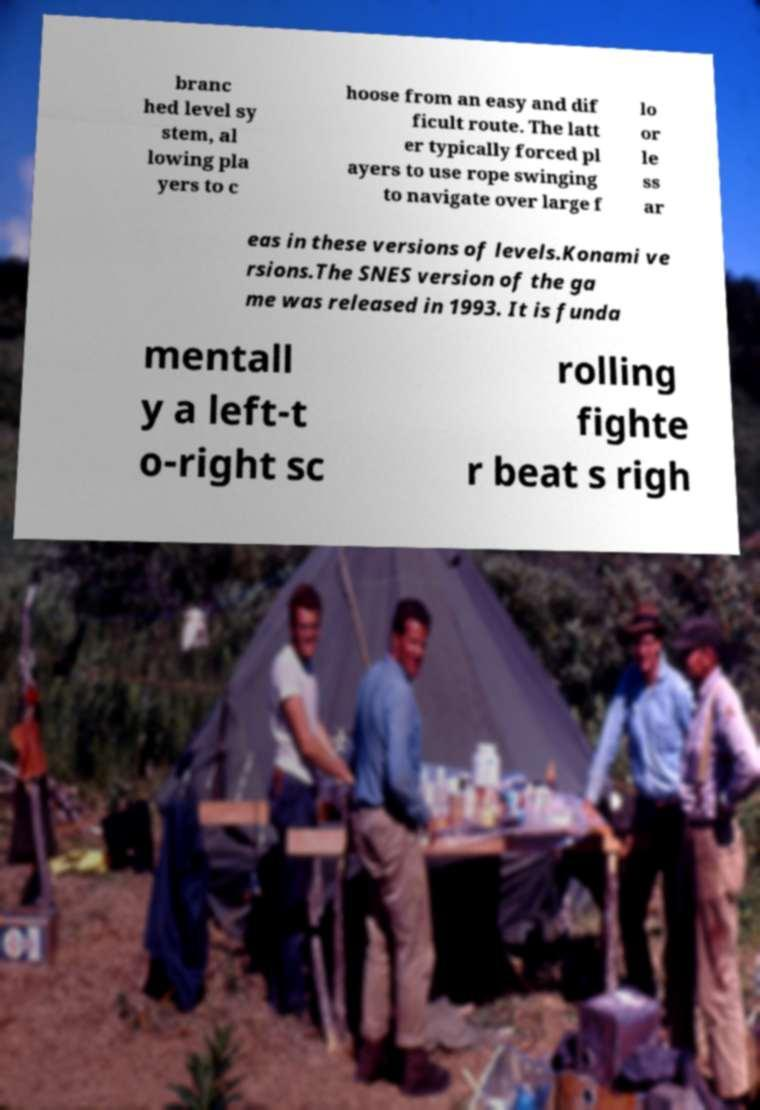For documentation purposes, I need the text within this image transcribed. Could you provide that? branc hed level sy stem, al lowing pla yers to c hoose from an easy and dif ficult route. The latt er typically forced pl ayers to use rope swinging to navigate over large f lo or le ss ar eas in these versions of levels.Konami ve rsions.The SNES version of the ga me was released in 1993. It is funda mentall y a left-t o-right sc rolling fighte r beat s righ 